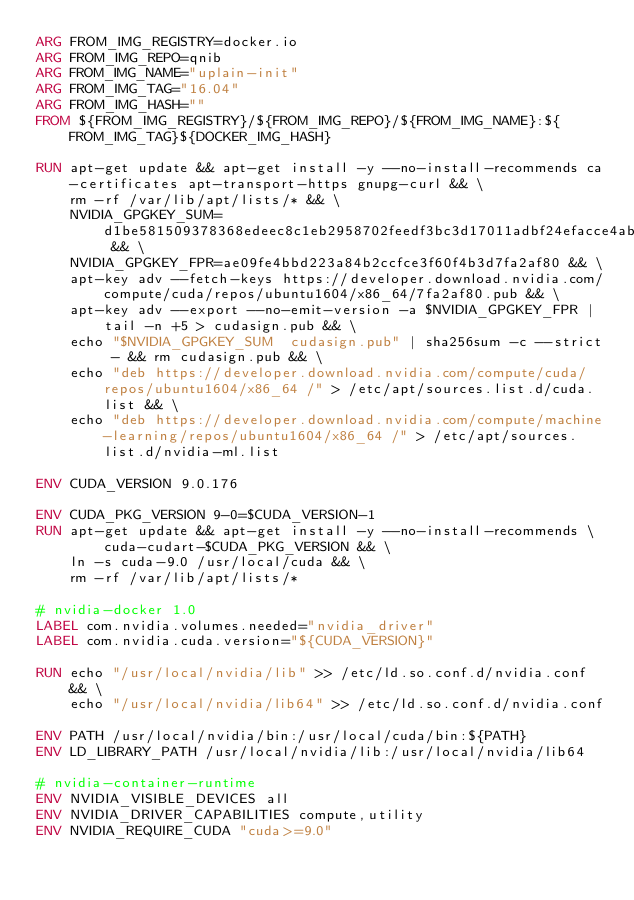Convert code to text. <code><loc_0><loc_0><loc_500><loc_500><_Dockerfile_>ARG FROM_IMG_REGISTRY=docker.io
ARG FROM_IMG_REPO=qnib
ARG FROM_IMG_NAME="uplain-init"
ARG FROM_IMG_TAG="16.04"
ARG FROM_IMG_HASH=""
FROM ${FROM_IMG_REGISTRY}/${FROM_IMG_REPO}/${FROM_IMG_NAME}:${FROM_IMG_TAG}${DOCKER_IMG_HASH}

RUN apt-get update && apt-get install -y --no-install-recommends ca-certificates apt-transport-https gnupg-curl && \
    rm -rf /var/lib/apt/lists/* && \
    NVIDIA_GPGKEY_SUM=d1be581509378368edeec8c1eb2958702feedf3bc3d17011adbf24efacce4ab5 && \
    NVIDIA_GPGKEY_FPR=ae09fe4bbd223a84b2ccfce3f60f4b3d7fa2af80 && \
    apt-key adv --fetch-keys https://developer.download.nvidia.com/compute/cuda/repos/ubuntu1604/x86_64/7fa2af80.pub && \
    apt-key adv --export --no-emit-version -a $NVIDIA_GPGKEY_FPR | tail -n +5 > cudasign.pub && \
    echo "$NVIDIA_GPGKEY_SUM  cudasign.pub" | sha256sum -c --strict - && rm cudasign.pub && \
    echo "deb https://developer.download.nvidia.com/compute/cuda/repos/ubuntu1604/x86_64 /" > /etc/apt/sources.list.d/cuda.list && \
    echo "deb https://developer.download.nvidia.com/compute/machine-learning/repos/ubuntu1604/x86_64 /" > /etc/apt/sources.list.d/nvidia-ml.list

ENV CUDA_VERSION 9.0.176

ENV CUDA_PKG_VERSION 9-0=$CUDA_VERSION-1
RUN apt-get update && apt-get install -y --no-install-recommends \
        cuda-cudart-$CUDA_PKG_VERSION && \
    ln -s cuda-9.0 /usr/local/cuda && \
    rm -rf /var/lib/apt/lists/*

# nvidia-docker 1.0
LABEL com.nvidia.volumes.needed="nvidia_driver"
LABEL com.nvidia.cuda.version="${CUDA_VERSION}"

RUN echo "/usr/local/nvidia/lib" >> /etc/ld.so.conf.d/nvidia.conf && \
    echo "/usr/local/nvidia/lib64" >> /etc/ld.so.conf.d/nvidia.conf

ENV PATH /usr/local/nvidia/bin:/usr/local/cuda/bin:${PATH}
ENV LD_LIBRARY_PATH /usr/local/nvidia/lib:/usr/local/nvidia/lib64

# nvidia-container-runtime
ENV NVIDIA_VISIBLE_DEVICES all
ENV NVIDIA_DRIVER_CAPABILITIES compute,utility
ENV NVIDIA_REQUIRE_CUDA "cuda>=9.0"
</code> 